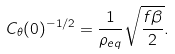Convert formula to latex. <formula><loc_0><loc_0><loc_500><loc_500>C _ { \theta } ( 0 ) ^ { - 1 / 2 } = \frac { 1 } { \rho _ { e q } } \sqrt { \frac { f \beta } { 2 } } .</formula> 